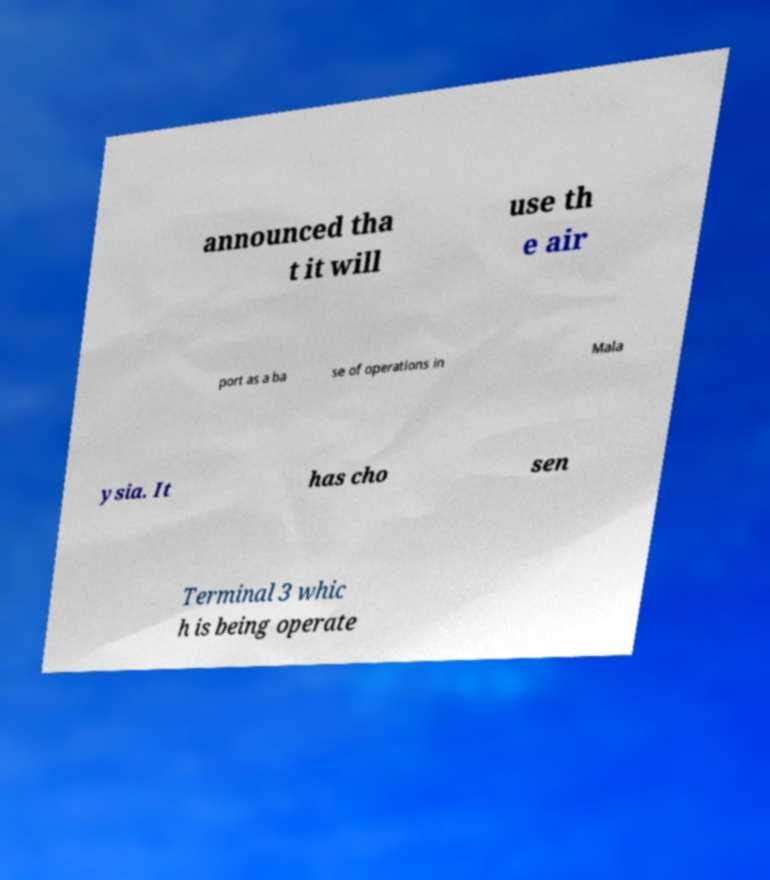Can you read and provide the text displayed in the image?This photo seems to have some interesting text. Can you extract and type it out for me? announced tha t it will use th e air port as a ba se of operations in Mala ysia. It has cho sen Terminal 3 whic h is being operate 